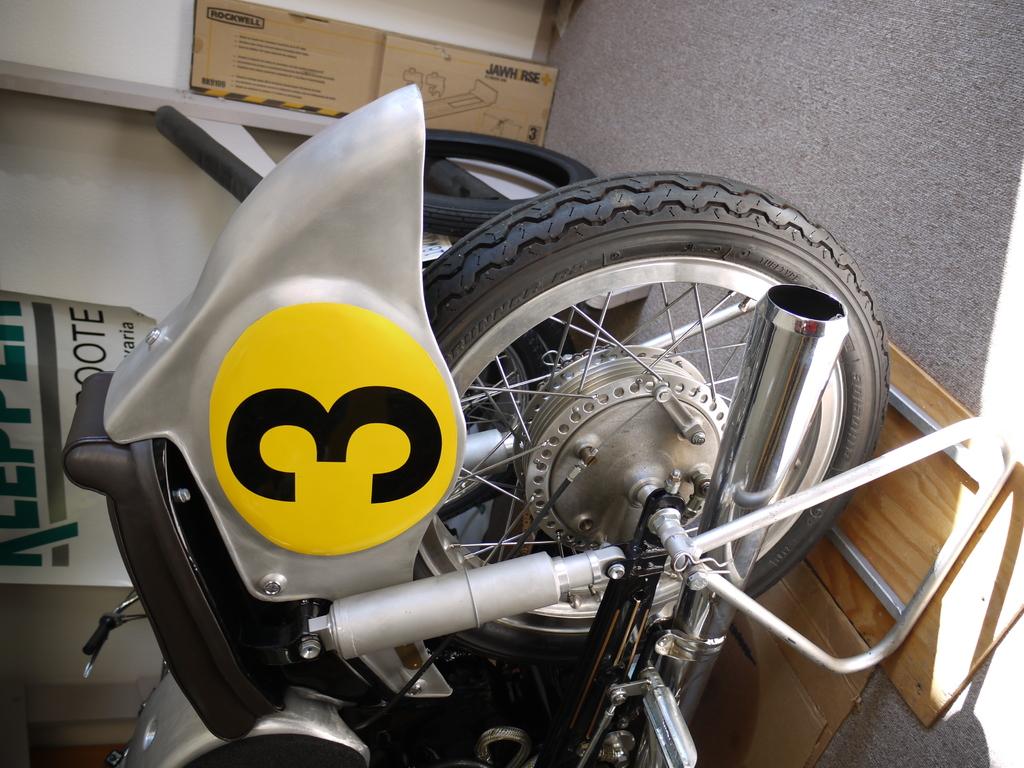What number is in the big yellow circle?
Your response must be concise. 3. 